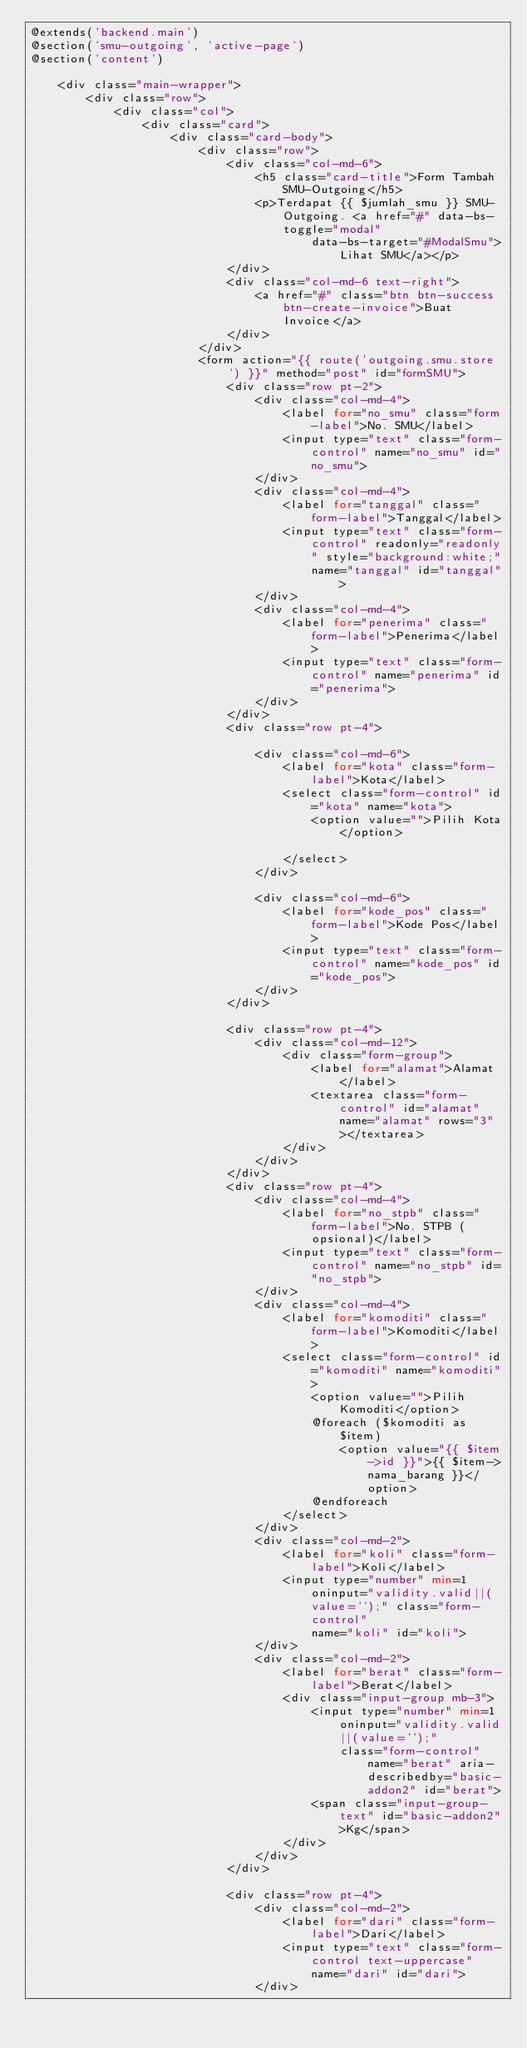Convert code to text. <code><loc_0><loc_0><loc_500><loc_500><_PHP_>@extends('backend.main')
@section('smu-outgoing', 'active-page')
@section('content')

    <div class="main-wrapper">
        <div class="row">
            <div class="col">
                <div class="card">
                    <div class="card-body">
                        <div class="row">
                            <div class="col-md-6">
                                <h5 class="card-title">Form Tambah SMU-Outgoing</h5>
                                <p>Terdapat {{ $jumlah_smu }} SMU-Outgoing. <a href="#" data-bs-toggle="modal"
                                        data-bs-target="#ModalSmu">Lihat SMU</a></p>
                            </div>
                            <div class="col-md-6 text-right">
                                <a href="#" class="btn btn-success btn-create-invoice">Buat
                                    Invoice</a>
                            </div>
                        </div>
                        <form action="{{ route('outgoing.smu.store') }}" method="post" id="formSMU">
                            <div class="row pt-2">
                                <div class="col-md-4">
                                    <label for="no_smu" class="form-label">No. SMU</label>
                                    <input type="text" class="form-control" name="no_smu" id="no_smu">
                                </div>
                                <div class="col-md-4">
                                    <label for="tanggal" class="form-label">Tanggal</label>
                                    <input type="text" class="form-control" readonly="readonly" style="background:white;"
                                        name="tanggal" id="tanggal">
                                </div>
                                <div class="col-md-4">
                                    <label for="penerima" class="form-label">Penerima</label>
                                    <input type="text" class="form-control" name="penerima" id="penerima">
                                </div>
                            </div>
                            <div class="row pt-4">

                                <div class="col-md-6">
                                    <label for="kota" class="form-label">Kota</label>
                                    <select class="form-control" id="kota" name="kota">
                                        <option value="">Pilih Kota</option>

                                    </select>
                                </div>

                                <div class="col-md-6">
                                    <label for="kode_pos" class="form-label">Kode Pos</label>
                                    <input type="text" class="form-control" name="kode_pos" id="kode_pos">
                                </div>
                            </div>

                            <div class="row pt-4">
                                <div class="col-md-12">
                                    <div class="form-group">
                                        <label for="alamat">Alamat</label>
                                        <textarea class="form-control" id="alamat" name="alamat" rows="3"></textarea>
                                    </div>
                                </div>
                            </div>
                            <div class="row pt-4">
                                <div class="col-md-4">
                                    <label for="no_stpb" class="form-label">No. STPB (opsional)</label>
                                    <input type="text" class="form-control" name="no_stpb" id="no_stpb">
                                </div>
                                <div class="col-md-4">
                                    <label for="komoditi" class="form-label">Komoditi</label>
                                    <select class="form-control" id="komoditi" name="komoditi">
                                        <option value="">Pilih Komoditi</option>
                                        @foreach ($komoditi as $item)
                                            <option value="{{ $item->id }}">{{ $item->nama_barang }}</option>
                                        @endforeach
                                    </select>
                                </div>
                                <div class="col-md-2">
                                    <label for="koli" class="form-label">Koli</label>
                                    <input type="number" min=1 oninput="validity.valid||(value='');" class="form-control"
                                        name="koli" id="koli">
                                </div>
                                <div class="col-md-2">
                                    <label for="berat" class="form-label">Berat</label>
                                    <div class="input-group mb-3">
                                        <input type="number" min=1 oninput="validity.valid||(value='');"
                                            class="form-control" name="berat" aria-describedby="basic-addon2" id="berat">
                                        <span class="input-group-text" id="basic-addon2">Kg</span>
                                    </div>
                                </div>
                            </div>

                            <div class="row pt-4">
                                <div class="col-md-2">
                                    <label for="dari" class="form-label">Dari</label>
                                    <input type="text" class="form-control text-uppercase" name="dari" id="dari">
                                </div></code> 